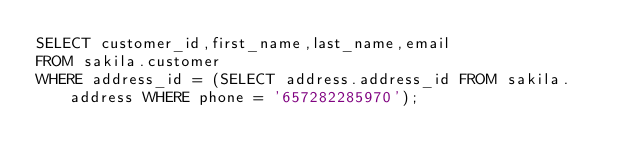Convert code to text. <code><loc_0><loc_0><loc_500><loc_500><_SQL_>SELECT customer_id,first_name,last_name,email
FROM sakila.customer
WHERE address_id = (SELECT address.address_id FROM sakila.address WHERE phone = '657282285970');</code> 